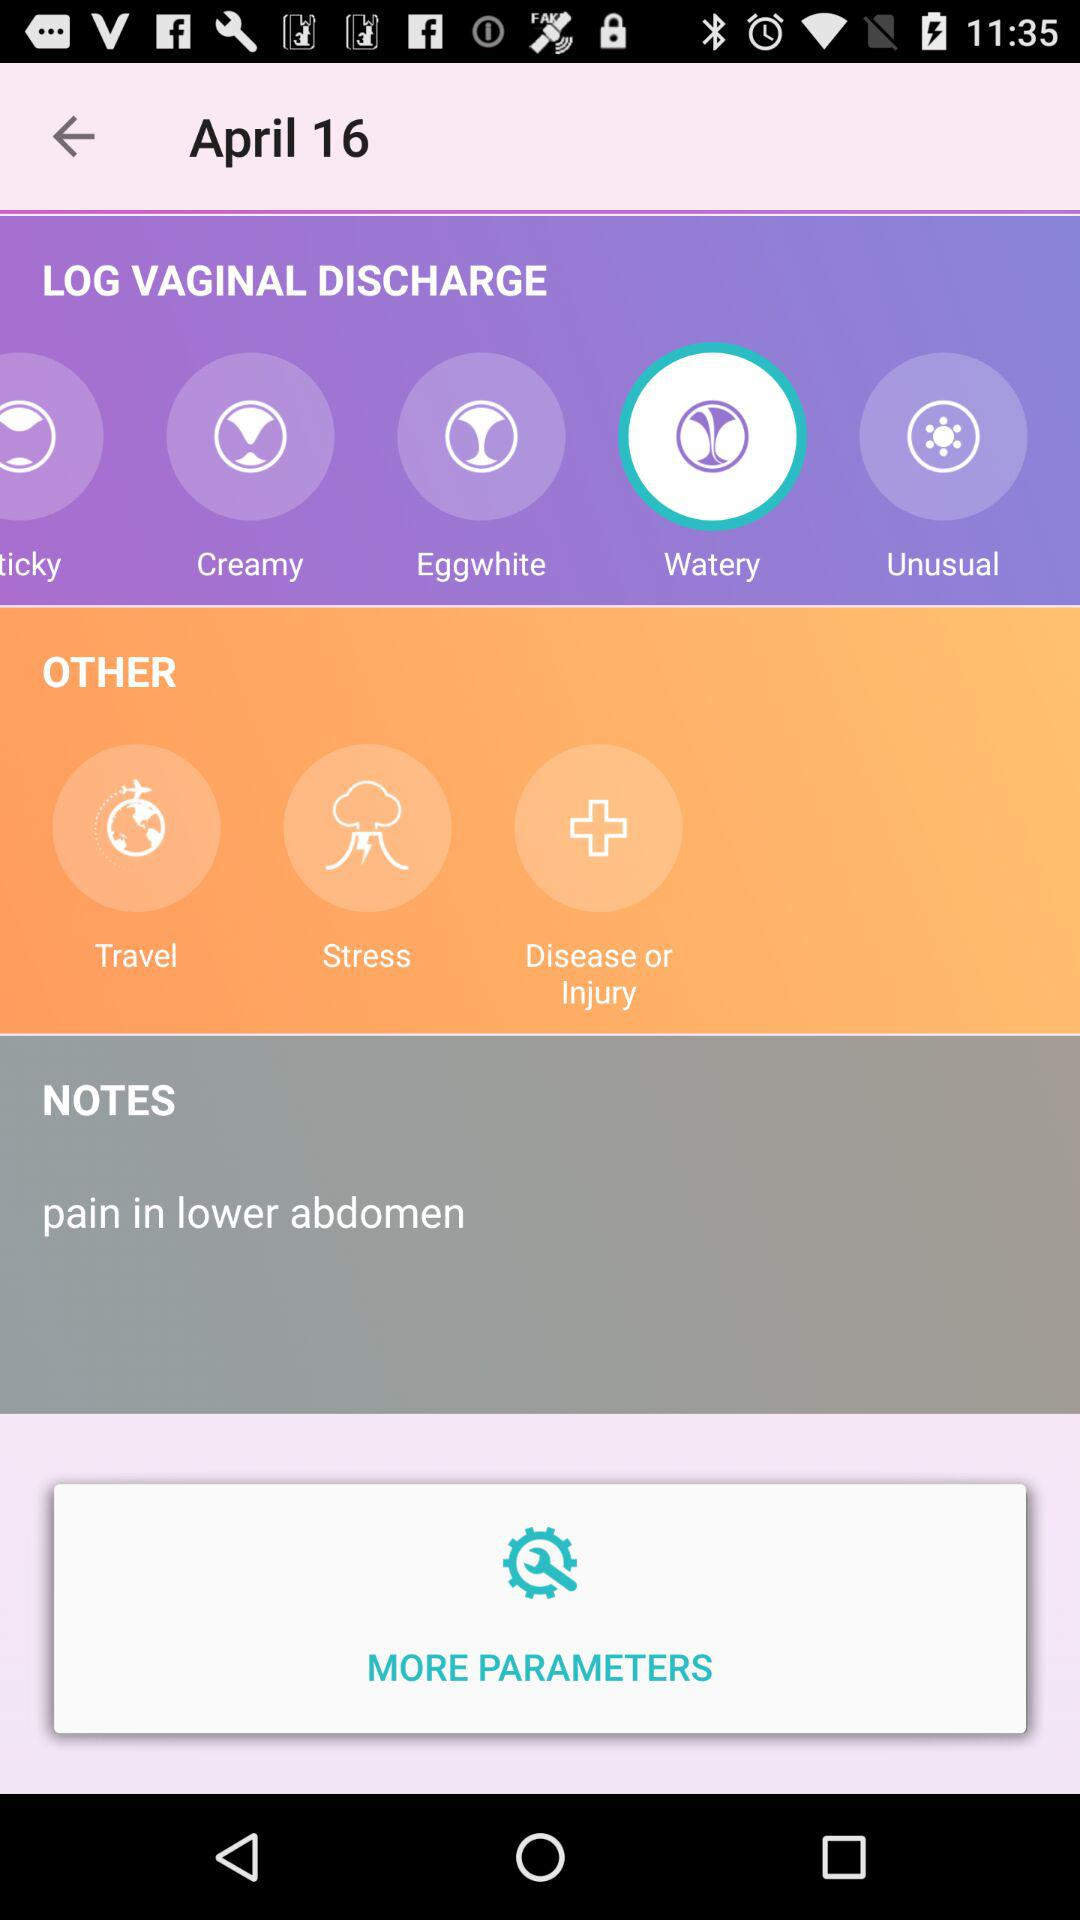What date is mentioned? The mentioned date is April 16. 